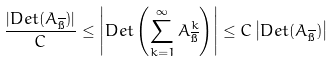Convert formula to latex. <formula><loc_0><loc_0><loc_500><loc_500>\frac { | D e t ( A _ { \overline { \i } } ) | } { C } \leq \left | D e t \left ( \sum _ { k = 1 } ^ { \infty } A _ { \overline { \i } } ^ { k } \right ) \right | \leq C \left | D e t ( A _ { \overline { \i } } ) \right |</formula> 